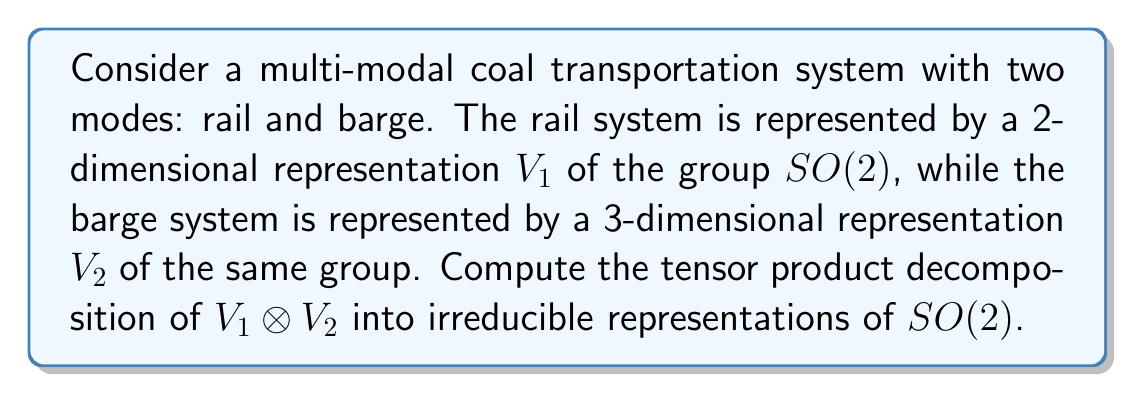Can you solve this math problem? To solve this problem, we follow these steps:

1) Recall that irreducible representations of $SO(2)$ are 1-dimensional and labeled by integers. Let's denote them as $\chi_n$ where $n \in \mathbb{Z}$.

2) For a 2-dimensional representation $V_1$ of $SO(2)$, it typically decomposes as:
   
   $$V_1 \cong \chi_1 \oplus \chi_{-1}$$

3) For a 3-dimensional representation $V_2$ of $SO(2)$, a common decomposition is:
   
   $$V_2 \cong \chi_0 \oplus \chi_1 \oplus \chi_{-1}$$

4) To compute $V_1 \otimes V_2$, we use the distributive property of tensor products:

   $$V_1 \otimes V_2 \cong (\chi_1 \oplus \chi_{-1}) \otimes (\chi_0 \oplus \chi_1 \oplus \chi_{-1})$$

5) Expanding this out:

   $$V_1 \otimes V_2 \cong (\chi_1 \otimes \chi_0) \oplus (\chi_1 \otimes \chi_1) \oplus (\chi_1 \otimes \chi_{-1}) \oplus (\chi_{-1} \otimes \chi_0) \oplus (\chi_{-1} \otimes \chi_1) \oplus (\chi_{-1} \otimes \chi_{-1})$$

6) Using the property that $\chi_a \otimes \chi_b \cong \chi_{a+b}$:

   $$V_1 \otimes V_2 \cong \chi_1 \oplus \chi_2 \oplus \chi_0 \oplus \chi_{-1} \oplus \chi_0 \oplus \chi_{-2}$$

7) Combining like terms:

   $$V_1 \otimes V_2 \cong \chi_{-2} \oplus \chi_{-1} \oplus \chi_0 \oplus \chi_0 \oplus \chi_1 \oplus \chi_2$$

This is the final decomposition into irreducible representations of $SO(2)$.
Answer: $\chi_{-2} \oplus \chi_{-1} \oplus \chi_0 \oplus \chi_0 \oplus \chi_1 \oplus \chi_2$ 